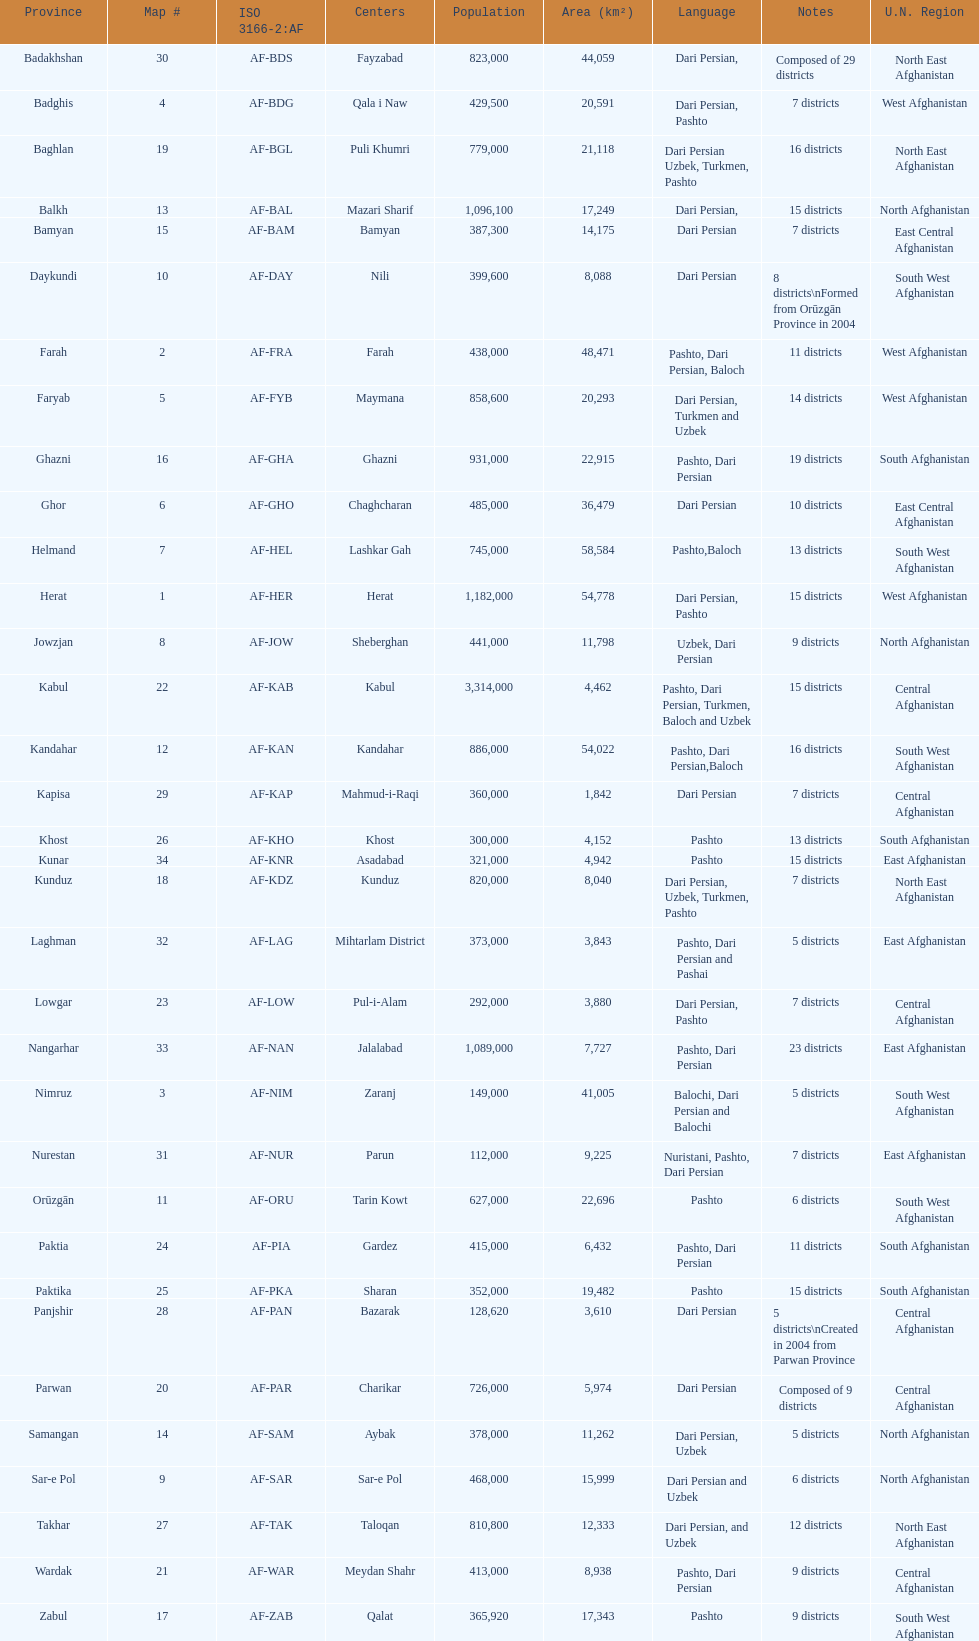Could you help me parse every detail presented in this table? {'header': ['Province', 'Map #', 'ISO 3166-2:AF', 'Centers', 'Population', 'Area (km²)', 'Language', 'Notes', 'U.N. Region'], 'rows': [['Badakhshan', '30', 'AF-BDS', 'Fayzabad', '823,000', '44,059', 'Dari Persian,', 'Composed of 29 districts', 'North East Afghanistan'], ['Badghis', '4', 'AF-BDG', 'Qala i Naw', '429,500', '20,591', 'Dari Persian, Pashto', '7 districts', 'West Afghanistan'], ['Baghlan', '19', 'AF-BGL', 'Puli Khumri', '779,000', '21,118', 'Dari Persian Uzbek, Turkmen, Pashto', '16 districts', 'North East Afghanistan'], ['Balkh', '13', 'AF-BAL', 'Mazari Sharif', '1,096,100', '17,249', 'Dari Persian,', '15 districts', 'North Afghanistan'], ['Bamyan', '15', 'AF-BAM', 'Bamyan', '387,300', '14,175', 'Dari Persian', '7 districts', 'East Central Afghanistan'], ['Daykundi', '10', 'AF-DAY', 'Nili', '399,600', '8,088', 'Dari Persian', '8 districts\\nFormed from Orūzgān Province in 2004', 'South West Afghanistan'], ['Farah', '2', 'AF-FRA', 'Farah', '438,000', '48,471', 'Pashto, Dari Persian, Baloch', '11 districts', 'West Afghanistan'], ['Faryab', '5', 'AF-FYB', 'Maymana', '858,600', '20,293', 'Dari Persian, Turkmen and Uzbek', '14 districts', 'West Afghanistan'], ['Ghazni', '16', 'AF-GHA', 'Ghazni', '931,000', '22,915', 'Pashto, Dari Persian', '19 districts', 'South Afghanistan'], ['Ghor', '6', 'AF-GHO', 'Chaghcharan', '485,000', '36,479', 'Dari Persian', '10 districts', 'East Central Afghanistan'], ['Helmand', '7', 'AF-HEL', 'Lashkar Gah', '745,000', '58,584', 'Pashto,Baloch', '13 districts', 'South West Afghanistan'], ['Herat', '1', 'AF-HER', 'Herat', '1,182,000', '54,778', 'Dari Persian, Pashto', '15 districts', 'West Afghanistan'], ['Jowzjan', '8', 'AF-JOW', 'Sheberghan', '441,000', '11,798', 'Uzbek, Dari Persian', '9 districts', 'North Afghanistan'], ['Kabul', '22', 'AF-KAB', 'Kabul', '3,314,000', '4,462', 'Pashto, Dari Persian, Turkmen, Baloch and Uzbek', '15 districts', 'Central Afghanistan'], ['Kandahar', '12', 'AF-KAN', 'Kandahar', '886,000', '54,022', 'Pashto, Dari Persian,Baloch', '16 districts', 'South West Afghanistan'], ['Kapisa', '29', 'AF-KAP', 'Mahmud-i-Raqi', '360,000', '1,842', 'Dari Persian', '7 districts', 'Central Afghanistan'], ['Khost', '26', 'AF-KHO', 'Khost', '300,000', '4,152', 'Pashto', '13 districts', 'South Afghanistan'], ['Kunar', '34', 'AF-KNR', 'Asadabad', '321,000', '4,942', 'Pashto', '15 districts', 'East Afghanistan'], ['Kunduz', '18', 'AF-KDZ', 'Kunduz', '820,000', '8,040', 'Dari Persian, Uzbek, Turkmen, Pashto', '7 districts', 'North East Afghanistan'], ['Laghman', '32', 'AF-LAG', 'Mihtarlam District', '373,000', '3,843', 'Pashto, Dari Persian and Pashai', '5 districts', 'East Afghanistan'], ['Lowgar', '23', 'AF-LOW', 'Pul-i-Alam', '292,000', '3,880', 'Dari Persian, Pashto', '7 districts', 'Central Afghanistan'], ['Nangarhar', '33', 'AF-NAN', 'Jalalabad', '1,089,000', '7,727', 'Pashto, Dari Persian', '23 districts', 'East Afghanistan'], ['Nimruz', '3', 'AF-NIM', 'Zaranj', '149,000', '41,005', 'Balochi, Dari Persian and Balochi', '5 districts', 'South West Afghanistan'], ['Nurestan', '31', 'AF-NUR', 'Parun', '112,000', '9,225', 'Nuristani, Pashto, Dari Persian', '7 districts', 'East Afghanistan'], ['Orūzgān', '11', 'AF-ORU', 'Tarin Kowt', '627,000', '22,696', 'Pashto', '6 districts', 'South West Afghanistan'], ['Paktia', '24', 'AF-PIA', 'Gardez', '415,000', '6,432', 'Pashto, Dari Persian', '11 districts', 'South Afghanistan'], ['Paktika', '25', 'AF-PKA', 'Sharan', '352,000', '19,482', 'Pashto', '15 districts', 'South Afghanistan'], ['Panjshir', '28', 'AF-PAN', 'Bazarak', '128,620', '3,610', 'Dari Persian', '5 districts\\nCreated in 2004 from Parwan Province', 'Central Afghanistan'], ['Parwan', '20', 'AF-PAR', 'Charikar', '726,000', '5,974', 'Dari Persian', 'Composed of 9 districts', 'Central Afghanistan'], ['Samangan', '14', 'AF-SAM', 'Aybak', '378,000', '11,262', 'Dari Persian, Uzbek', '5 districts', 'North Afghanistan'], ['Sar-e Pol', '9', 'AF-SAR', 'Sar-e Pol', '468,000', '15,999', 'Dari Persian and Uzbek', '6 districts', 'North Afghanistan'], ['Takhar', '27', 'AF-TAK', 'Taloqan', '810,800', '12,333', 'Dari Persian, and Uzbek', '12 districts', 'North East Afghanistan'], ['Wardak', '21', 'AF-WAR', 'Meydan Shahr', '413,000', '8,938', 'Pashto, Dari Persian', '9 districts', 'Central Afghanistan'], ['Zabul', '17', 'AF-ZAB', 'Qalat', '365,920', '17,343', 'Pashto', '9 districts', 'South West Afghanistan']]} What province is listed previous to ghor? Ghazni. 